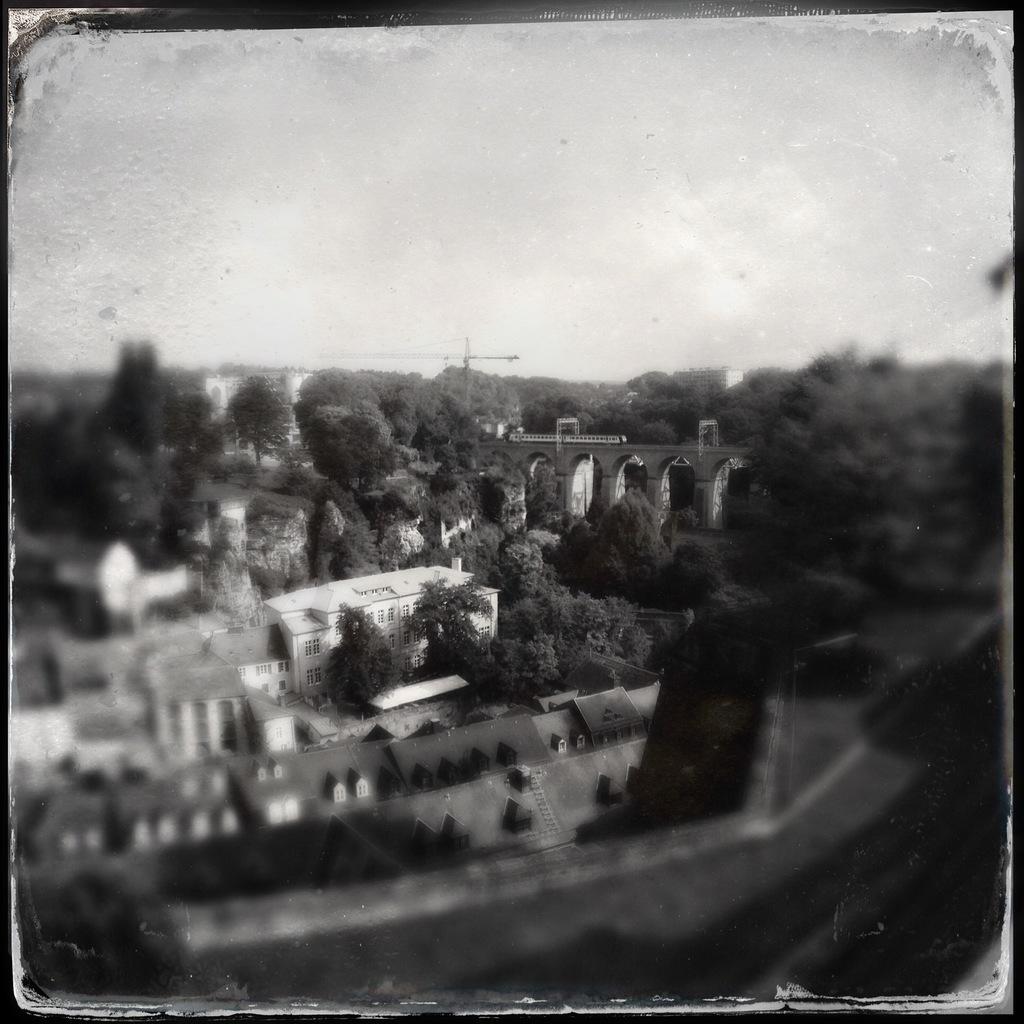Can you describe this image briefly? This picture is an edited picture. In this image there are buildings and trees. At the top there is sky. 